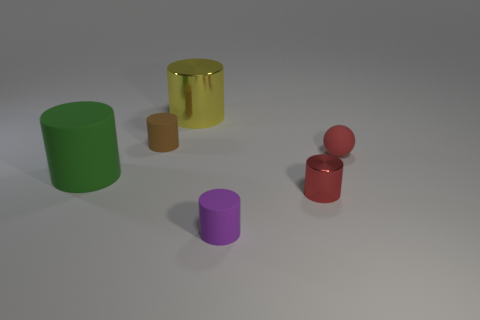There is a cylinder right of the small rubber cylinder right of the large metallic cylinder; what is it made of? metal 